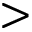<formula> <loc_0><loc_0><loc_500><loc_500>></formula> 